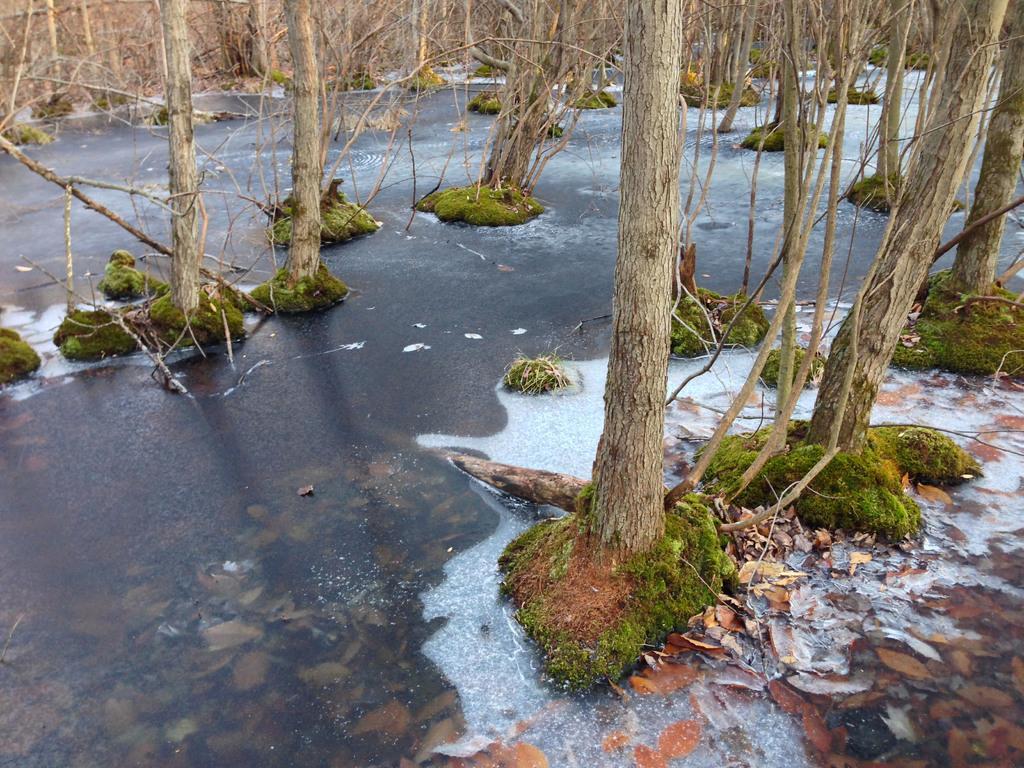Can you describe this image briefly? In this image we can see the trees, dried leaves and also the water. 